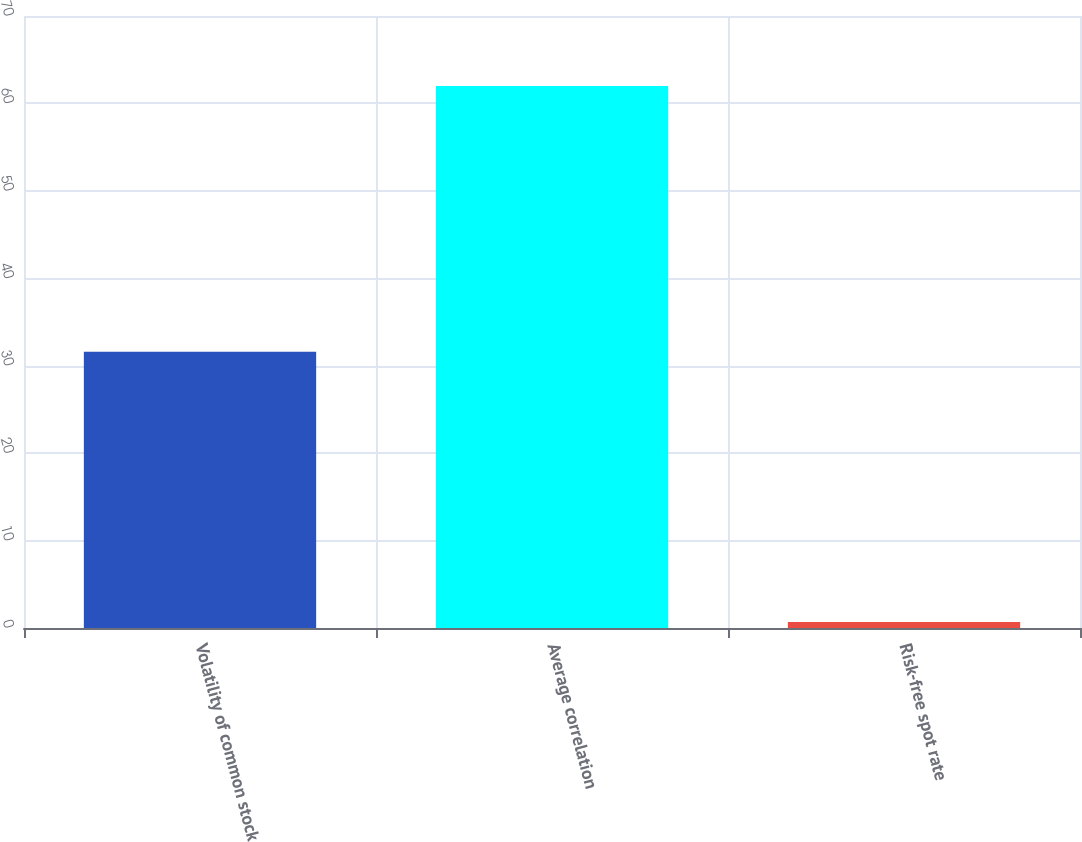Convert chart to OTSL. <chart><loc_0><loc_0><loc_500><loc_500><bar_chart><fcel>Volatility of common stock<fcel>Average correlation<fcel>Risk-free spot rate<nl><fcel>31.6<fcel>62<fcel>0.7<nl></chart> 